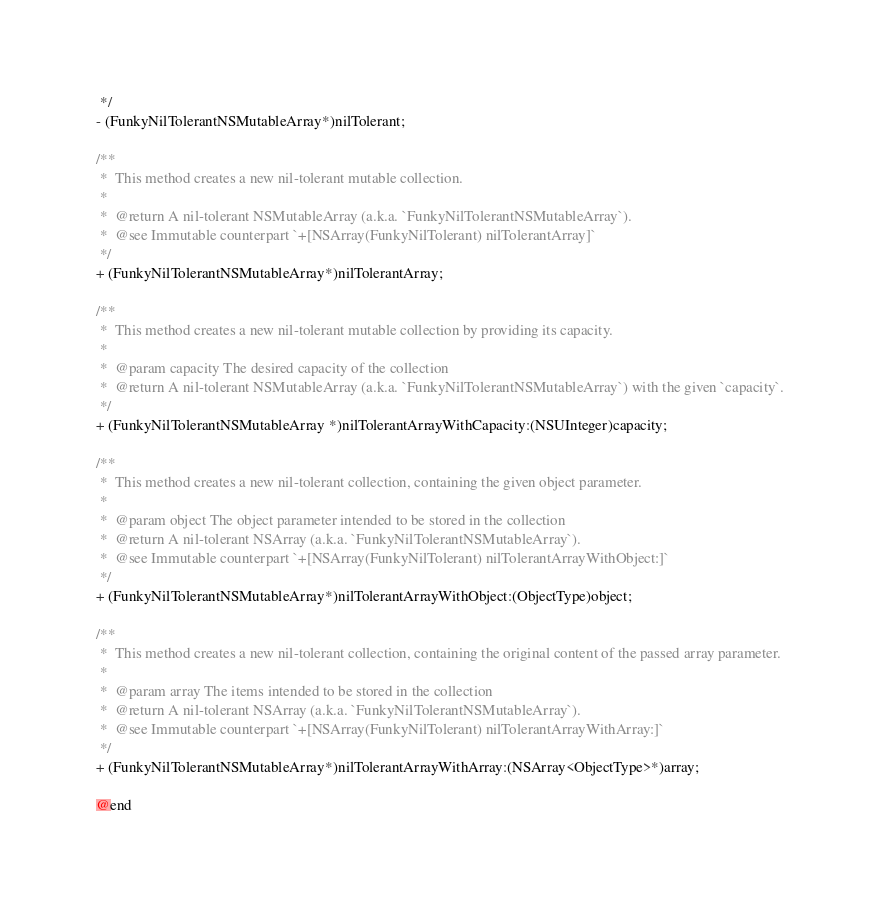Convert code to text. <code><loc_0><loc_0><loc_500><loc_500><_C_> */
- (FunkyNilTolerantNSMutableArray*)nilTolerant;

/**
 *  This method creates a new nil-tolerant mutable collection.
 *
 *  @return A nil-tolerant NSMutableArray (a.k.a. `FunkyNilTolerantNSMutableArray`).
 *  @see Immutable counterpart `+[NSArray(FunkyNilTolerant) nilTolerantArray]`
 */
+ (FunkyNilTolerantNSMutableArray*)nilTolerantArray;

/**
 *  This method creates a new nil-tolerant mutable collection by providing its capacity.
 *
 *  @param capacity The desired capacity of the collection
 *  @return A nil-tolerant NSMutableArray (a.k.a. `FunkyNilTolerantNSMutableArray`) with the given `capacity`.
 */
+ (FunkyNilTolerantNSMutableArray *)nilTolerantArrayWithCapacity:(NSUInteger)capacity;

/**
 *  This method creates a new nil-tolerant collection, containing the given object parameter.
 *
 *  @param object The object parameter intended to be stored in the collection
 *  @return A nil-tolerant NSArray (a.k.a. `FunkyNilTolerantNSMutableArray`).
 *  @see Immutable counterpart `+[NSArray(FunkyNilTolerant) nilTolerantArrayWithObject:]`
 */
+ (FunkyNilTolerantNSMutableArray*)nilTolerantArrayWithObject:(ObjectType)object;

/**
 *  This method creates a new nil-tolerant collection, containing the original content of the passed array parameter.
 *
 *  @param array The items intended to be stored in the collection
 *  @return A nil-tolerant NSArray (a.k.a. `FunkyNilTolerantNSMutableArray`).
 *  @see Immutable counterpart `+[NSArray(FunkyNilTolerant) nilTolerantArrayWithArray:]`
 */
+ (FunkyNilTolerantNSMutableArray*)nilTolerantArrayWithArray:(NSArray<ObjectType>*)array;

@end
</code> 